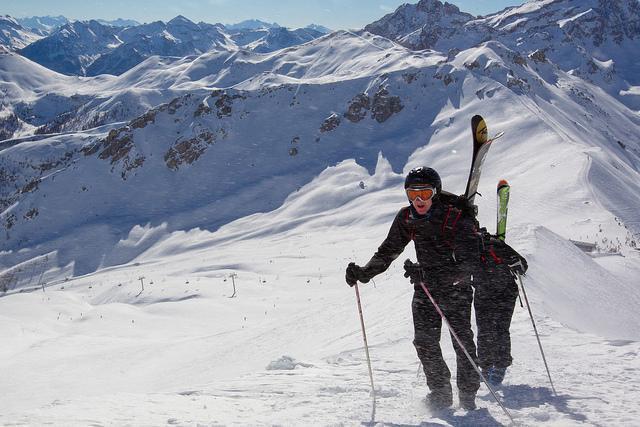What is the primary color of the skis carried on the back of the man following the man?
Indicate the correct response and explain using: 'Answer: answer
Rationale: rationale.'
Options: Black, green, red, yellow. Answer: green.
Rationale: The color is green. 